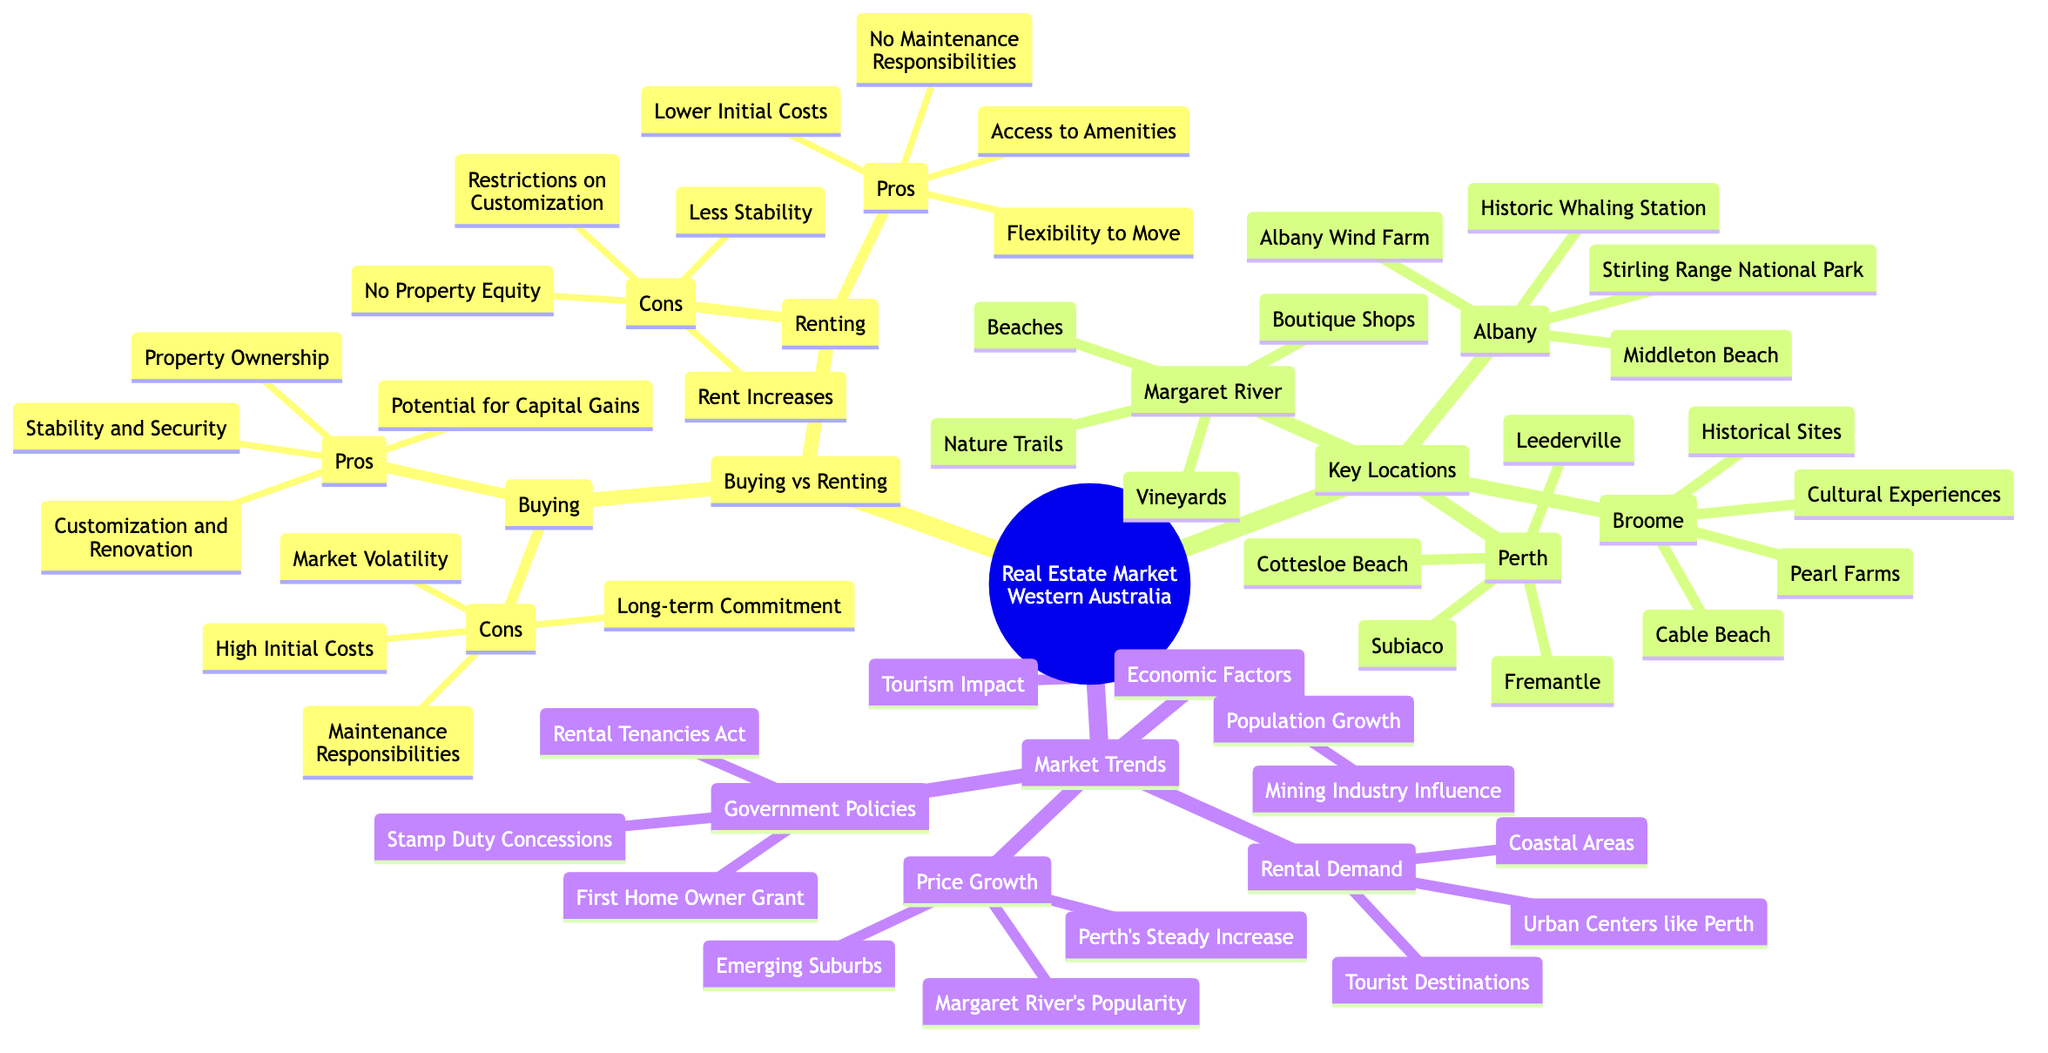What are the pros of buying property? The diagram lists “Property Ownership,” “Potential for Capital Gains,” “Stability and Security,” and “Customization and Renovation” as the pros of buying property under the “Buying” category.
Answer: Property Ownership, Potential for Capital Gains, Stability and Security, Customization and Renovation What are the key locations mentioned for Western Australia? The diagram details four key locations: "Perth," "Margaret River," "Broome," and "Albany." Each location has specific attractions listed under it.
Answer: Perth, Margaret River, Broome, Albany What is a con of renting? A con of renting from the diagram includes “No Property Equity,” “Rent Increases,” “Less Stability,” and “Restrictions on Customization.” Any of these can be considered a con.
Answer: No Property Equity, Rent Increases, Less Stability, Restrictions on Customization What has been the rental demand trend in Western Australia? The diagram states that rental demand is particularly high in “Coastal Areas,” “Urban Centers like Perth,” and “Tourist Destinations.” These three aspects describe rental demand effectively.
Answer: Coastal Areas, Urban Centers like Perth, Tourist Destinations Which location has a historical site as one of its attractions? The diagram indicates under “Broome” that “Historical Sites” is one of the attractions associated with that location.
Answer: Historical Sites How does the mining industry influence the real estate market? The diagram describes “Mining Industry Influence” as one of the economic factors affecting the real estate market, suggesting it plays a significant role in shaping trends.
Answer: Mining Industry Influence Which pros of buying property relate to financial benefits? The financial benefits listed in the diagram for buying property are “Potential for Capital Gains” and “Property Ownership,” connecting these areas to economics.
Answer: Potential for Capital Gains, Property Ownership Which suburb is experiencing steady price growth? The diagram mentions “Perth's Steady Increase” in the context of price growth, indicating that Perth is a suburb that has been consistent in increasing property prices.
Answer: Perth's Steady Increase What is one government policy mentioned that supports first-time home buyers? Among the various government policies listed in the diagram, the “First Home Owner Grant” specifically supports first-time home buyers in their purchases.
Answer: First Home Owner Grant 